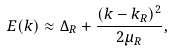Convert formula to latex. <formula><loc_0><loc_0><loc_500><loc_500>E ( k ) \approx \Delta _ { R } + \frac { ( k - k _ { R } ) ^ { 2 } } { 2 \mu _ { R } } ,</formula> 